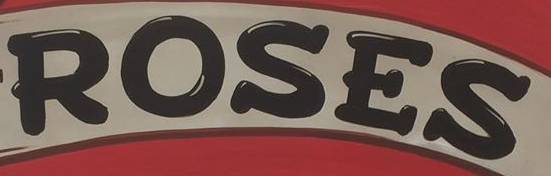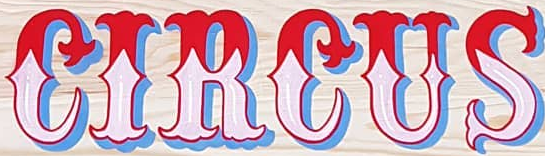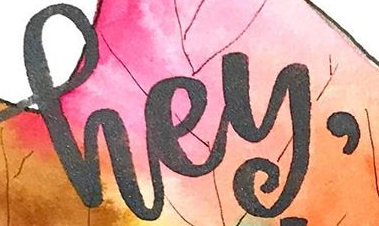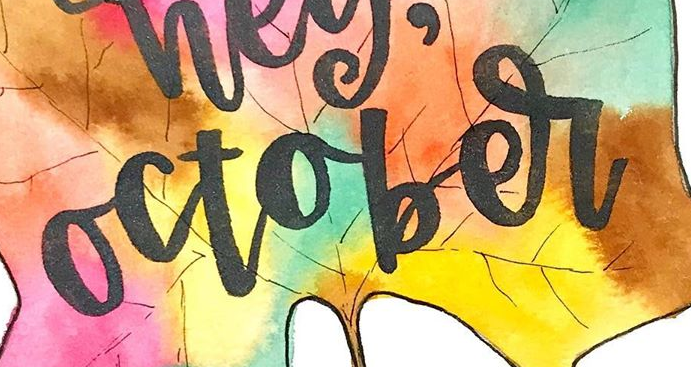What words can you see in these images in sequence, separated by a semicolon? ROSES; CIRCUS; hey,; october 